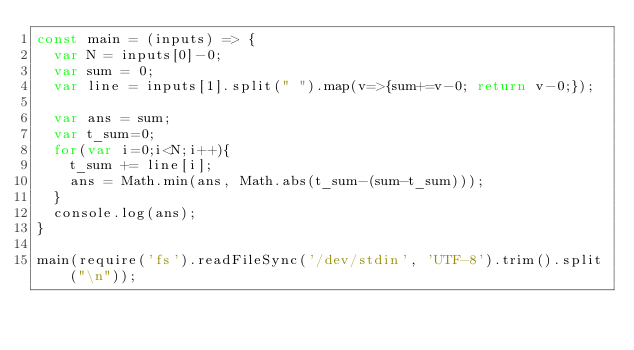<code> <loc_0><loc_0><loc_500><loc_500><_JavaScript_>const main = (inputs) => {
  var N = inputs[0]-0;
  var sum = 0;
  var line = inputs[1].split(" ").map(v=>{sum+=v-0; return v-0;});

  var ans = sum;
  var t_sum=0;
  for(var i=0;i<N;i++){
    t_sum += line[i];
    ans = Math.min(ans, Math.abs(t_sum-(sum-t_sum)));
  }
  console.log(ans);
}

main(require('fs').readFileSync('/dev/stdin', 'UTF-8').trim().split("\n"));
</code> 